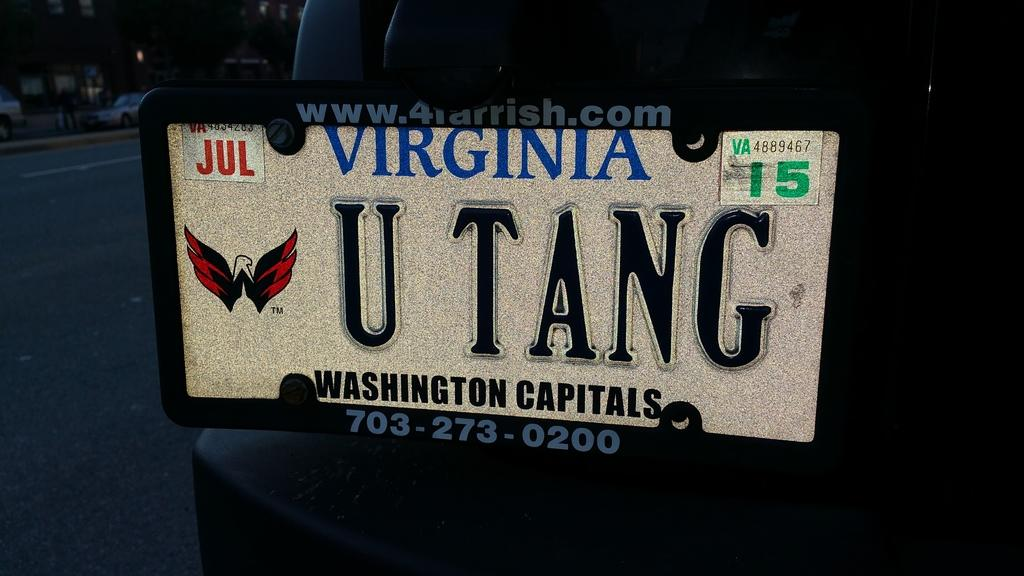<image>
Write a terse but informative summary of the picture. Virginia tag that says U TANG and expired in 2015. 